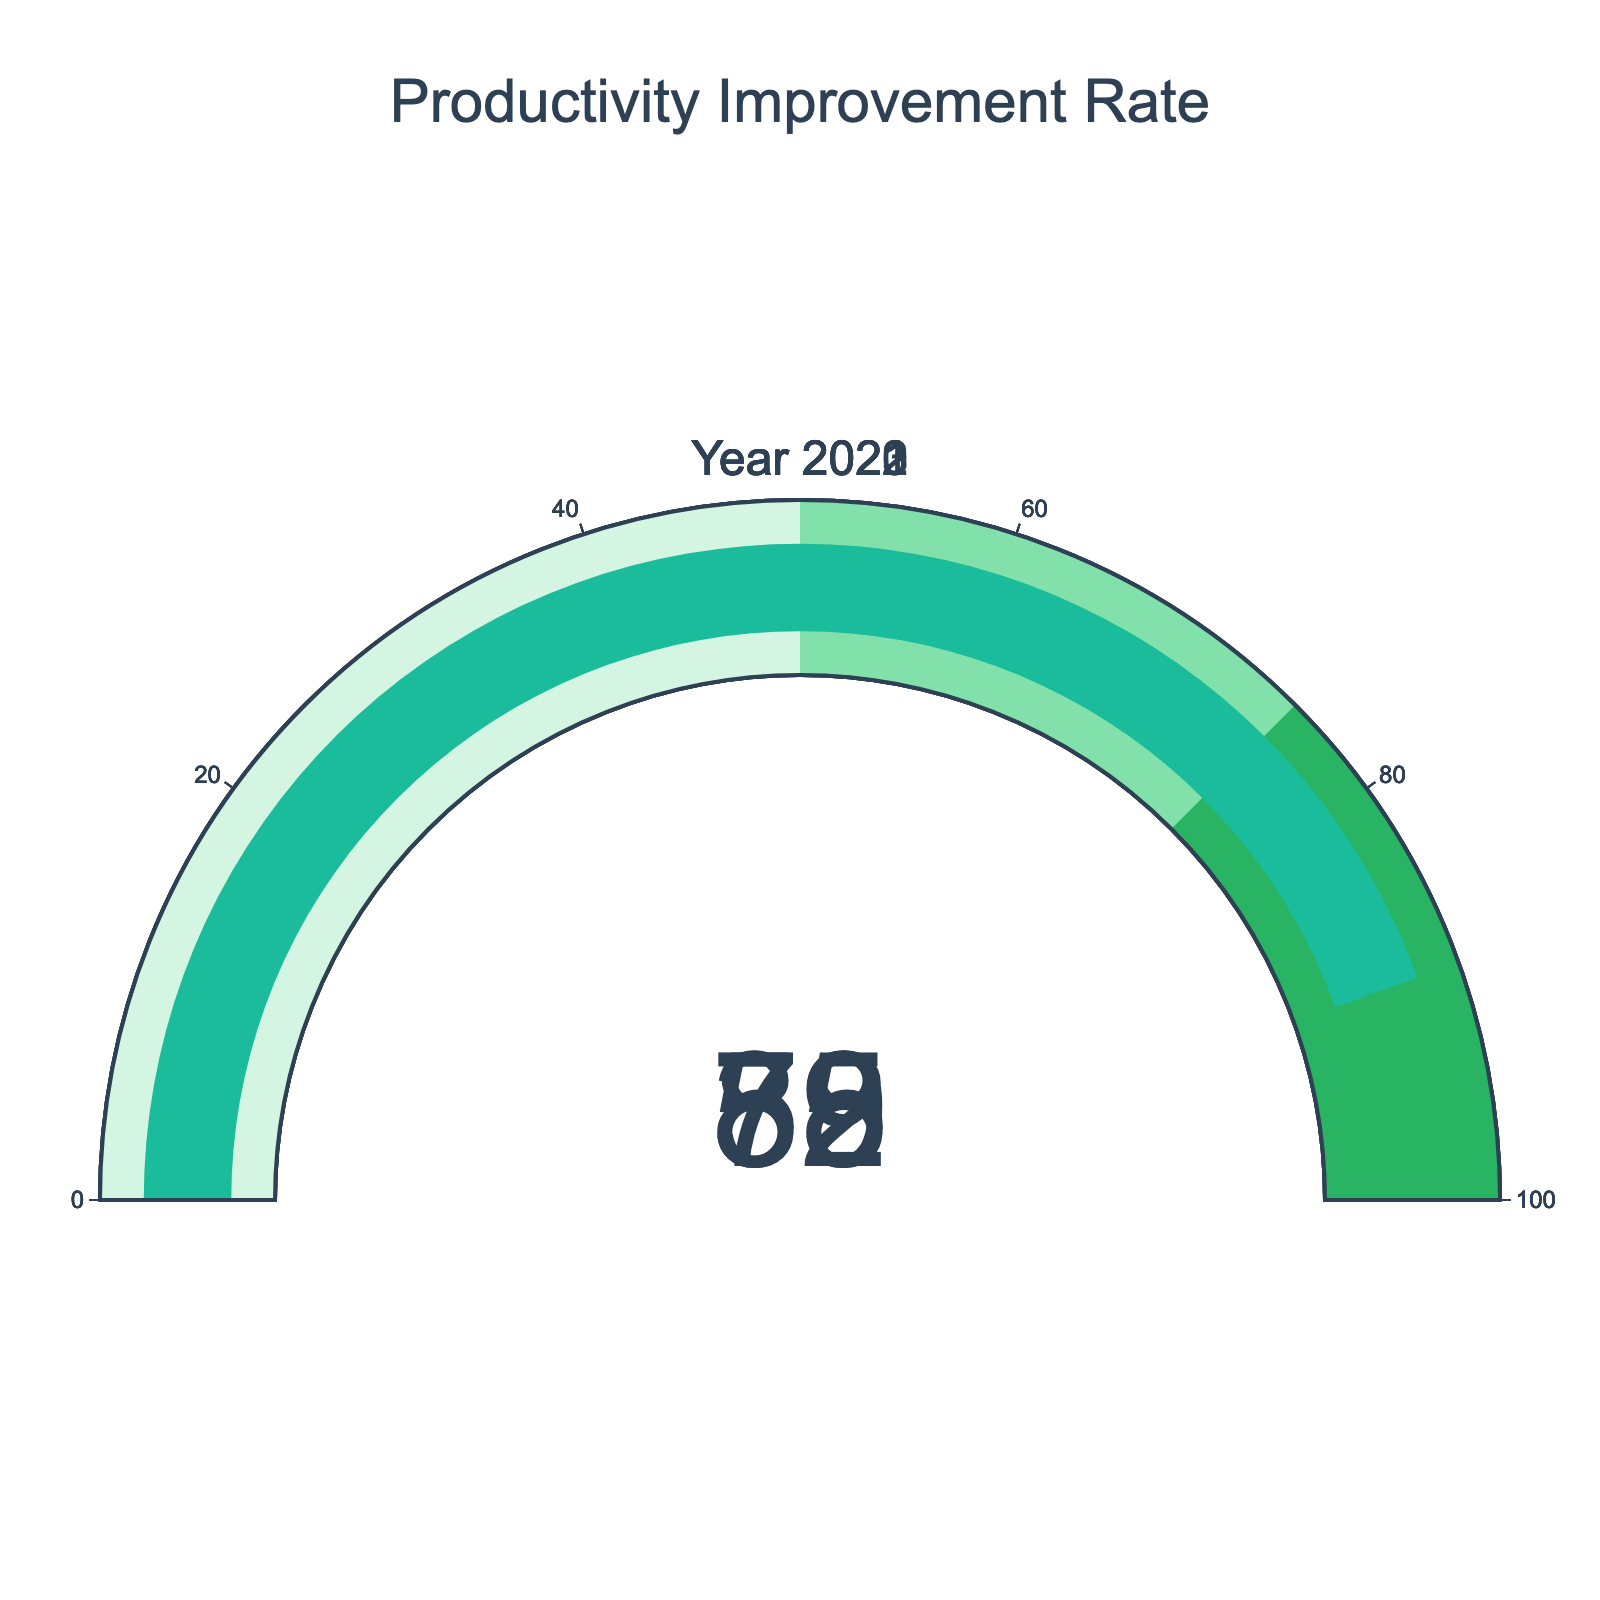What's the title of the chart? The title of the chart is located at the top and reads "Productivity Improvement Rate".
Answer: Productivity Improvement Rate What is the productivity improvement rate for the year 2020? Check the gauge labeled "Year 2020". The value in the center of the gauge indicates the productivity improvement rate.
Answer: 32 Which year saw the highest productivity improvement rate? Compare the values shown in the center of each gauge labeled with the respective year to determine the highest value.
Answer: 2023 What's the difference in the productivity improvement rates between 2022 and 2020? Subtract the value in the 2020 gauge from the value in the 2022 gauge. (75 - 32)
Answer: 43 What color does the bar turn when the productivity improvement rate is above 75? Observe the color of the bar in the gauges corresponding to values above 75, specifically the gauges for 2022 and 2023.
Answer: Green Which year falls within the productivity improvement range of 50 to 75? Look at the gauges with values that fall between 50 and 75 and check their corresponding year.
Answer: 2021 Calculate the average productivity improvement rate across all years displayed. Add up all productivity rates (32 + 58 + 75 + 89) and divide by the number of years (4). The calculation is (32 + 58 + 75 + 89) / 4.
Answer: 63.5 Out of the years presented, which two have a productivity improvement rate greater than 58? Identify the gauges with values greater than 58 and note the corresponding years.
Answer: 2022, 2023 How many gauges indicate a productivity improvement rate above the 50% mark? Count the gauges where the indicated productivity improvement rate is above 50%.
Answer: 3 